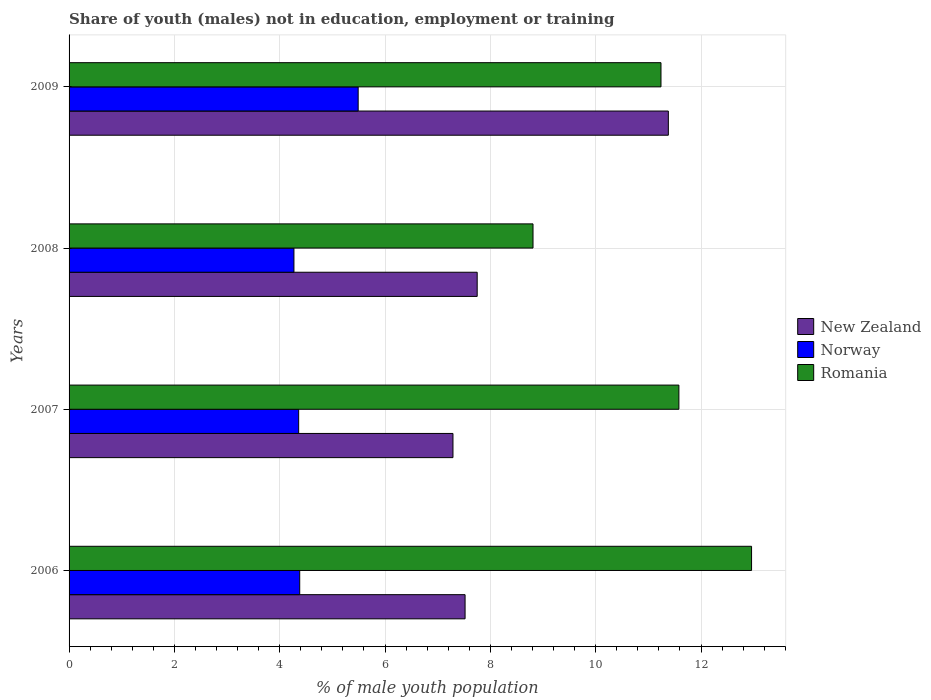How many bars are there on the 3rd tick from the bottom?
Provide a short and direct response. 3. In how many cases, is the number of bars for a given year not equal to the number of legend labels?
Your answer should be compact. 0. What is the percentage of unemployed males population in in Norway in 2009?
Provide a short and direct response. 5.49. Across all years, what is the maximum percentage of unemployed males population in in Romania?
Your answer should be compact. 12.96. Across all years, what is the minimum percentage of unemployed males population in in New Zealand?
Your answer should be very brief. 7.29. In which year was the percentage of unemployed males population in in Norway maximum?
Give a very brief answer. 2009. What is the total percentage of unemployed males population in in Norway in the graph?
Make the answer very short. 18.5. What is the difference between the percentage of unemployed males population in in Norway in 2007 and that in 2009?
Your answer should be compact. -1.13. What is the difference between the percentage of unemployed males population in in Norway in 2006 and the percentage of unemployed males population in in Romania in 2008?
Offer a terse response. -4.43. What is the average percentage of unemployed males population in in New Zealand per year?
Make the answer very short. 8.49. In the year 2008, what is the difference between the percentage of unemployed males population in in Norway and percentage of unemployed males population in in New Zealand?
Provide a succinct answer. -3.48. What is the ratio of the percentage of unemployed males population in in Romania in 2006 to that in 2007?
Provide a short and direct response. 1.12. What is the difference between the highest and the second highest percentage of unemployed males population in in New Zealand?
Your response must be concise. 3.63. What is the difference between the highest and the lowest percentage of unemployed males population in in Norway?
Provide a short and direct response. 1.22. In how many years, is the percentage of unemployed males population in in New Zealand greater than the average percentage of unemployed males population in in New Zealand taken over all years?
Offer a terse response. 1. What does the 2nd bar from the bottom in 2008 represents?
Make the answer very short. Norway. Does the graph contain any zero values?
Make the answer very short. No. Where does the legend appear in the graph?
Provide a succinct answer. Center right. How many legend labels are there?
Ensure brevity in your answer.  3. What is the title of the graph?
Provide a succinct answer. Share of youth (males) not in education, employment or training. Does "American Samoa" appear as one of the legend labels in the graph?
Offer a terse response. No. What is the label or title of the X-axis?
Ensure brevity in your answer.  % of male youth population. What is the label or title of the Y-axis?
Provide a short and direct response. Years. What is the % of male youth population of New Zealand in 2006?
Your response must be concise. 7.52. What is the % of male youth population in Norway in 2006?
Give a very brief answer. 4.38. What is the % of male youth population of Romania in 2006?
Your answer should be very brief. 12.96. What is the % of male youth population in New Zealand in 2007?
Give a very brief answer. 7.29. What is the % of male youth population of Norway in 2007?
Provide a succinct answer. 4.36. What is the % of male youth population of Romania in 2007?
Provide a short and direct response. 11.58. What is the % of male youth population in New Zealand in 2008?
Offer a very short reply. 7.75. What is the % of male youth population in Norway in 2008?
Provide a succinct answer. 4.27. What is the % of male youth population in Romania in 2008?
Give a very brief answer. 8.81. What is the % of male youth population of New Zealand in 2009?
Your response must be concise. 11.38. What is the % of male youth population in Norway in 2009?
Your answer should be compact. 5.49. What is the % of male youth population of Romania in 2009?
Make the answer very short. 11.24. Across all years, what is the maximum % of male youth population of New Zealand?
Keep it short and to the point. 11.38. Across all years, what is the maximum % of male youth population in Norway?
Offer a very short reply. 5.49. Across all years, what is the maximum % of male youth population of Romania?
Ensure brevity in your answer.  12.96. Across all years, what is the minimum % of male youth population in New Zealand?
Offer a very short reply. 7.29. Across all years, what is the minimum % of male youth population of Norway?
Keep it short and to the point. 4.27. Across all years, what is the minimum % of male youth population in Romania?
Your answer should be very brief. 8.81. What is the total % of male youth population in New Zealand in the graph?
Your answer should be very brief. 33.94. What is the total % of male youth population in Norway in the graph?
Ensure brevity in your answer.  18.5. What is the total % of male youth population in Romania in the graph?
Provide a succinct answer. 44.59. What is the difference between the % of male youth population of New Zealand in 2006 and that in 2007?
Offer a very short reply. 0.23. What is the difference between the % of male youth population in Romania in 2006 and that in 2007?
Ensure brevity in your answer.  1.38. What is the difference between the % of male youth population of New Zealand in 2006 and that in 2008?
Keep it short and to the point. -0.23. What is the difference between the % of male youth population in Norway in 2006 and that in 2008?
Your response must be concise. 0.11. What is the difference between the % of male youth population of Romania in 2006 and that in 2008?
Give a very brief answer. 4.15. What is the difference between the % of male youth population of New Zealand in 2006 and that in 2009?
Keep it short and to the point. -3.86. What is the difference between the % of male youth population in Norway in 2006 and that in 2009?
Offer a terse response. -1.11. What is the difference between the % of male youth population of Romania in 2006 and that in 2009?
Make the answer very short. 1.72. What is the difference between the % of male youth population of New Zealand in 2007 and that in 2008?
Make the answer very short. -0.46. What is the difference between the % of male youth population of Norway in 2007 and that in 2008?
Make the answer very short. 0.09. What is the difference between the % of male youth population of Romania in 2007 and that in 2008?
Give a very brief answer. 2.77. What is the difference between the % of male youth population in New Zealand in 2007 and that in 2009?
Provide a short and direct response. -4.09. What is the difference between the % of male youth population of Norway in 2007 and that in 2009?
Your answer should be compact. -1.13. What is the difference between the % of male youth population in Romania in 2007 and that in 2009?
Ensure brevity in your answer.  0.34. What is the difference between the % of male youth population in New Zealand in 2008 and that in 2009?
Give a very brief answer. -3.63. What is the difference between the % of male youth population of Norway in 2008 and that in 2009?
Provide a short and direct response. -1.22. What is the difference between the % of male youth population of Romania in 2008 and that in 2009?
Give a very brief answer. -2.43. What is the difference between the % of male youth population of New Zealand in 2006 and the % of male youth population of Norway in 2007?
Keep it short and to the point. 3.16. What is the difference between the % of male youth population in New Zealand in 2006 and the % of male youth population in Romania in 2007?
Provide a succinct answer. -4.06. What is the difference between the % of male youth population in Norway in 2006 and the % of male youth population in Romania in 2007?
Keep it short and to the point. -7.2. What is the difference between the % of male youth population of New Zealand in 2006 and the % of male youth population of Norway in 2008?
Offer a terse response. 3.25. What is the difference between the % of male youth population in New Zealand in 2006 and the % of male youth population in Romania in 2008?
Provide a succinct answer. -1.29. What is the difference between the % of male youth population in Norway in 2006 and the % of male youth population in Romania in 2008?
Your answer should be very brief. -4.43. What is the difference between the % of male youth population in New Zealand in 2006 and the % of male youth population in Norway in 2009?
Ensure brevity in your answer.  2.03. What is the difference between the % of male youth population in New Zealand in 2006 and the % of male youth population in Romania in 2009?
Give a very brief answer. -3.72. What is the difference between the % of male youth population of Norway in 2006 and the % of male youth population of Romania in 2009?
Give a very brief answer. -6.86. What is the difference between the % of male youth population in New Zealand in 2007 and the % of male youth population in Norway in 2008?
Provide a short and direct response. 3.02. What is the difference between the % of male youth population of New Zealand in 2007 and the % of male youth population of Romania in 2008?
Ensure brevity in your answer.  -1.52. What is the difference between the % of male youth population in Norway in 2007 and the % of male youth population in Romania in 2008?
Offer a terse response. -4.45. What is the difference between the % of male youth population of New Zealand in 2007 and the % of male youth population of Romania in 2009?
Your response must be concise. -3.95. What is the difference between the % of male youth population of Norway in 2007 and the % of male youth population of Romania in 2009?
Provide a short and direct response. -6.88. What is the difference between the % of male youth population in New Zealand in 2008 and the % of male youth population in Norway in 2009?
Offer a terse response. 2.26. What is the difference between the % of male youth population in New Zealand in 2008 and the % of male youth population in Romania in 2009?
Keep it short and to the point. -3.49. What is the difference between the % of male youth population of Norway in 2008 and the % of male youth population of Romania in 2009?
Keep it short and to the point. -6.97. What is the average % of male youth population in New Zealand per year?
Keep it short and to the point. 8.48. What is the average % of male youth population in Norway per year?
Provide a short and direct response. 4.62. What is the average % of male youth population in Romania per year?
Your answer should be very brief. 11.15. In the year 2006, what is the difference between the % of male youth population of New Zealand and % of male youth population of Norway?
Your response must be concise. 3.14. In the year 2006, what is the difference between the % of male youth population of New Zealand and % of male youth population of Romania?
Offer a terse response. -5.44. In the year 2006, what is the difference between the % of male youth population of Norway and % of male youth population of Romania?
Your response must be concise. -8.58. In the year 2007, what is the difference between the % of male youth population of New Zealand and % of male youth population of Norway?
Give a very brief answer. 2.93. In the year 2007, what is the difference between the % of male youth population of New Zealand and % of male youth population of Romania?
Offer a very short reply. -4.29. In the year 2007, what is the difference between the % of male youth population of Norway and % of male youth population of Romania?
Make the answer very short. -7.22. In the year 2008, what is the difference between the % of male youth population in New Zealand and % of male youth population in Norway?
Your answer should be very brief. 3.48. In the year 2008, what is the difference between the % of male youth population in New Zealand and % of male youth population in Romania?
Offer a very short reply. -1.06. In the year 2008, what is the difference between the % of male youth population of Norway and % of male youth population of Romania?
Offer a terse response. -4.54. In the year 2009, what is the difference between the % of male youth population of New Zealand and % of male youth population of Norway?
Offer a terse response. 5.89. In the year 2009, what is the difference between the % of male youth population of New Zealand and % of male youth population of Romania?
Keep it short and to the point. 0.14. In the year 2009, what is the difference between the % of male youth population of Norway and % of male youth population of Romania?
Keep it short and to the point. -5.75. What is the ratio of the % of male youth population in New Zealand in 2006 to that in 2007?
Provide a succinct answer. 1.03. What is the ratio of the % of male youth population in Norway in 2006 to that in 2007?
Give a very brief answer. 1. What is the ratio of the % of male youth population of Romania in 2006 to that in 2007?
Ensure brevity in your answer.  1.12. What is the ratio of the % of male youth population in New Zealand in 2006 to that in 2008?
Ensure brevity in your answer.  0.97. What is the ratio of the % of male youth population in Norway in 2006 to that in 2008?
Offer a very short reply. 1.03. What is the ratio of the % of male youth population in Romania in 2006 to that in 2008?
Offer a very short reply. 1.47. What is the ratio of the % of male youth population in New Zealand in 2006 to that in 2009?
Your response must be concise. 0.66. What is the ratio of the % of male youth population of Norway in 2006 to that in 2009?
Your response must be concise. 0.8. What is the ratio of the % of male youth population of Romania in 2006 to that in 2009?
Give a very brief answer. 1.15. What is the ratio of the % of male youth population in New Zealand in 2007 to that in 2008?
Offer a terse response. 0.94. What is the ratio of the % of male youth population in Norway in 2007 to that in 2008?
Give a very brief answer. 1.02. What is the ratio of the % of male youth population of Romania in 2007 to that in 2008?
Offer a very short reply. 1.31. What is the ratio of the % of male youth population in New Zealand in 2007 to that in 2009?
Provide a succinct answer. 0.64. What is the ratio of the % of male youth population in Norway in 2007 to that in 2009?
Offer a very short reply. 0.79. What is the ratio of the % of male youth population of Romania in 2007 to that in 2009?
Give a very brief answer. 1.03. What is the ratio of the % of male youth population of New Zealand in 2008 to that in 2009?
Your answer should be compact. 0.68. What is the ratio of the % of male youth population of Norway in 2008 to that in 2009?
Keep it short and to the point. 0.78. What is the ratio of the % of male youth population in Romania in 2008 to that in 2009?
Keep it short and to the point. 0.78. What is the difference between the highest and the second highest % of male youth population of New Zealand?
Offer a terse response. 3.63. What is the difference between the highest and the second highest % of male youth population of Norway?
Offer a terse response. 1.11. What is the difference between the highest and the second highest % of male youth population of Romania?
Provide a succinct answer. 1.38. What is the difference between the highest and the lowest % of male youth population of New Zealand?
Provide a succinct answer. 4.09. What is the difference between the highest and the lowest % of male youth population of Norway?
Your response must be concise. 1.22. What is the difference between the highest and the lowest % of male youth population in Romania?
Your response must be concise. 4.15. 